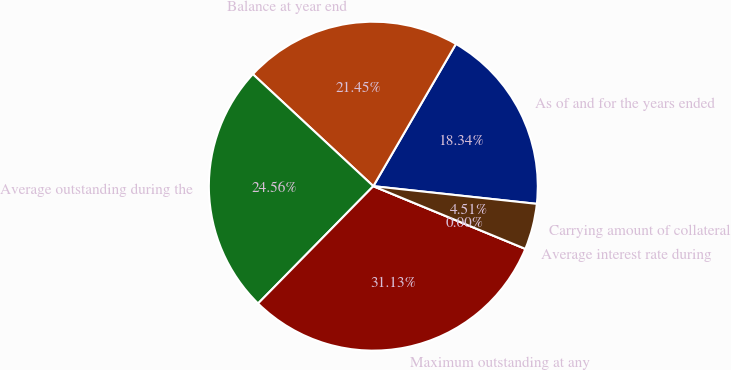Convert chart. <chart><loc_0><loc_0><loc_500><loc_500><pie_chart><fcel>As of and for the years ended<fcel>Balance at year end<fcel>Average outstanding during the<fcel>Maximum outstanding at any<fcel>Average interest rate during<fcel>Carrying amount of collateral<nl><fcel>18.34%<fcel>21.45%<fcel>24.56%<fcel>31.13%<fcel>0.0%<fcel>4.51%<nl></chart> 